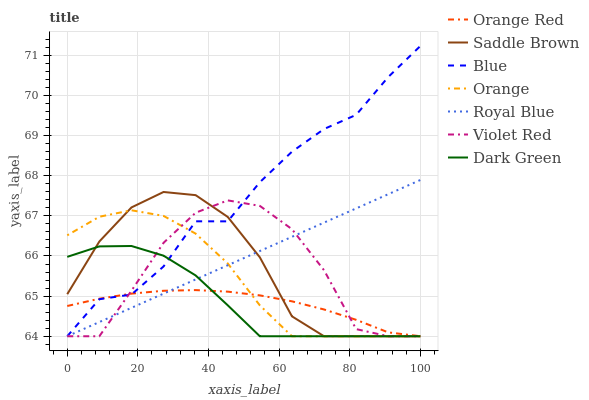Does Orange Red have the minimum area under the curve?
Answer yes or no. Yes. Does Blue have the maximum area under the curve?
Answer yes or no. Yes. Does Violet Red have the minimum area under the curve?
Answer yes or no. No. Does Violet Red have the maximum area under the curve?
Answer yes or no. No. Is Royal Blue the smoothest?
Answer yes or no. Yes. Is Violet Red the roughest?
Answer yes or no. Yes. Is Saddle Brown the smoothest?
Answer yes or no. No. Is Saddle Brown the roughest?
Answer yes or no. No. Does Blue have the lowest value?
Answer yes or no. Yes. Does Blue have the highest value?
Answer yes or no. Yes. Does Violet Red have the highest value?
Answer yes or no. No. Does Saddle Brown intersect Orange?
Answer yes or no. Yes. Is Saddle Brown less than Orange?
Answer yes or no. No. Is Saddle Brown greater than Orange?
Answer yes or no. No. 